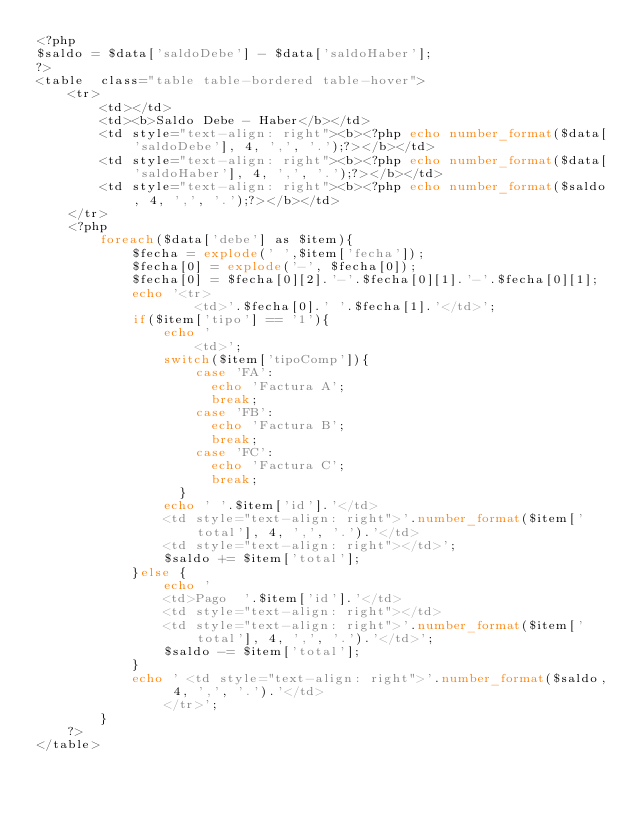<code> <loc_0><loc_0><loc_500><loc_500><_PHP_><?php 
$saldo = $data['saldoDebe'] - $data['saldoHaber'];
?>
<table  class="table table-bordered table-hover">
    <tr>
        <td></td>
        <td><b>Saldo Debe - Haber</b></td>
        <td style="text-align: right"><b><?php echo number_format($data['saldoDebe'], 4, ',', '.');?></b></td>
        <td style="text-align: right"><b><?php echo number_format($data['saldoHaber'], 4, ',', '.');?></b></td>
        <td style="text-align: right"><b><?php echo number_format($saldo, 4, ',', '.');?></b></td>
    </tr>
    <?php
        foreach($data['debe'] as $item){
            $fecha = explode(' ',$item['fecha']);
            $fecha[0] = explode('-', $fecha[0]);
            $fecha[0] = $fecha[0][2].'-'.$fecha[0][1].'-'.$fecha[0][1];
            echo '<tr>
                    <td>'.$fecha[0].' '.$fecha[1].'</td>';
            if($item['tipo'] == '1'){
                echo '
                    <td>';
                switch($item['tipoComp']){
                    case 'FA':
                      echo 'Factura A';
                      break;
                    case 'FB':
                      echo 'Factura B';
                      break;
                    case 'FC':
                      echo 'Factura C';
                      break;
                  }
                echo ' '.$item['id'].'</td>
                <td style="text-align: right">'.number_format($item['total'], 4, ',', '.').'</td>
                <td style="text-align: right"></td>';
                $saldo += $item['total'];
            }else {
                echo '
                <td>Pago  '.$item['id'].'</td>
                <td style="text-align: right"></td>
                <td style="text-align: right">'.number_format($item['total'], 4, ',', '.').'</td>';
                $saldo -= $item['total'];
            }
            echo ' <td style="text-align: right">'.number_format($saldo, 4, ',', '.').'</td>
                </tr>';
        }
    ?>
</table></code> 